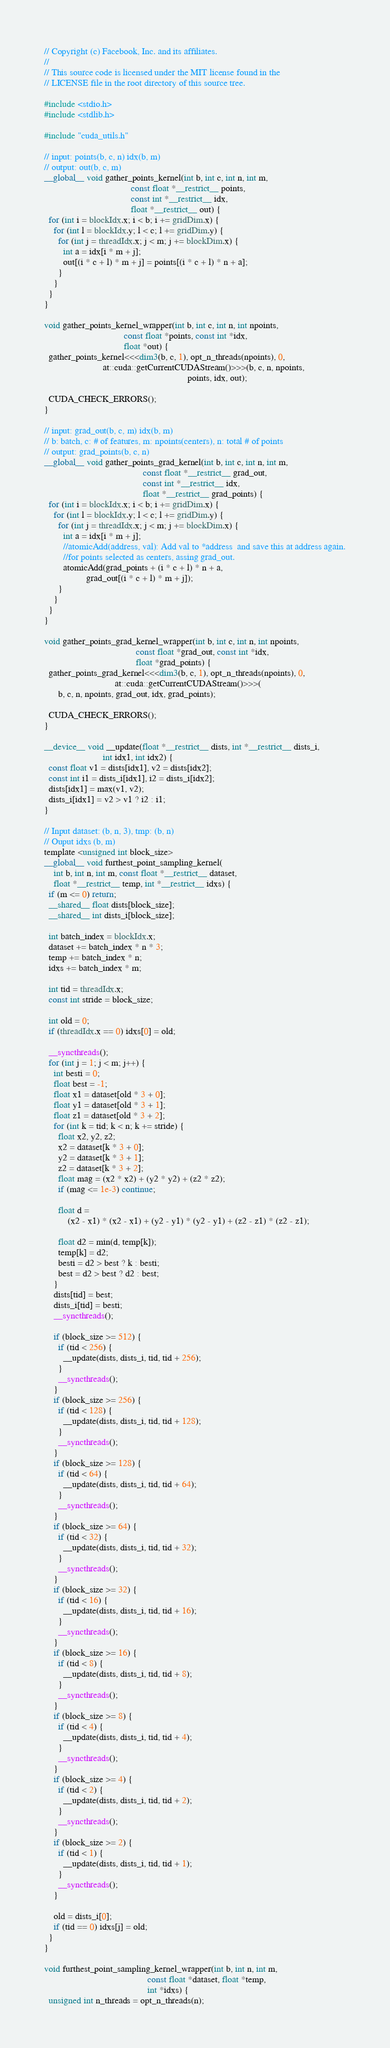Convert code to text. <code><loc_0><loc_0><loc_500><loc_500><_Cuda_>// Copyright (c) Facebook, Inc. and its affiliates.
// 
// This source code is licensed under the MIT license found in the
// LICENSE file in the root directory of this source tree.

#include <stdio.h>
#include <stdlib.h>

#include "cuda_utils.h"

// input: points(b, c, n) idx(b, m)
// output: out(b, c, m)
__global__ void gather_points_kernel(int b, int c, int n, int m,
                                     const float *__restrict__ points,
                                     const int *__restrict__ idx,
                                     float *__restrict__ out) {
  for (int i = blockIdx.x; i < b; i += gridDim.x) {
    for (int l = blockIdx.y; l < c; l += gridDim.y) {
      for (int j = threadIdx.x; j < m; j += blockDim.x) {
        int a = idx[i * m + j];
        out[(i * c + l) * m + j] = points[(i * c + l) * n + a];
      }
    }
  }
}

void gather_points_kernel_wrapper(int b, int c, int n, int npoints,
                                  const float *points, const int *idx,
                                  float *out) {
  gather_points_kernel<<<dim3(b, c, 1), opt_n_threads(npoints), 0,
                         at::cuda::getCurrentCUDAStream()>>>(b, c, n, npoints,
                                                             points, idx, out);

  CUDA_CHECK_ERRORS();
}

// input: grad_out(b, c, m) idx(b, m)
// b: batch, c: # of features, m: npoints(centers), n: total # of points
// output: grad_points(b, c, n)
__global__ void gather_points_grad_kernel(int b, int c, int n, int m,
                                          const float *__restrict__ grad_out,
                                          const int *__restrict__ idx,
                                          float *__restrict__ grad_points) {
  for (int i = blockIdx.x; i < b; i += gridDim.x) {
    for (int l = blockIdx.y; l < c; l += gridDim.y) {
      for (int j = threadIdx.x; j < m; j += blockDim.x) {
        int a = idx[i * m + j];
        //atomicAdd(address, val): Add val to *address  and save this at address again.
        //for points selected as centers, assing grad_out.
        atomicAdd(grad_points + (i * c + l) * n + a,
                  grad_out[(i * c + l) * m + j]);
      }
    }
  }
}

void gather_points_grad_kernel_wrapper(int b, int c, int n, int npoints,
                                       const float *grad_out, const int *idx,
                                       float *grad_points) {
  gather_points_grad_kernel<<<dim3(b, c, 1), opt_n_threads(npoints), 0,
                              at::cuda::getCurrentCUDAStream()>>>(
      b, c, n, npoints, grad_out, idx, grad_points);

  CUDA_CHECK_ERRORS();
}

__device__ void __update(float *__restrict__ dists, int *__restrict__ dists_i,
                         int idx1, int idx2) {
  const float v1 = dists[idx1], v2 = dists[idx2];
  const int i1 = dists_i[idx1], i2 = dists_i[idx2];
  dists[idx1] = max(v1, v2);
  dists_i[idx1] = v2 > v1 ? i2 : i1;
}

// Input dataset: (b, n, 3), tmp: (b, n)
// Ouput idxs (b, m)
template <unsigned int block_size>
__global__ void furthest_point_sampling_kernel(
    int b, int n, int m, const float *__restrict__ dataset,
    float *__restrict__ temp, int *__restrict__ idxs) {
  if (m <= 0) return;
  __shared__ float dists[block_size];
  __shared__ int dists_i[block_size];

  int batch_index = blockIdx.x;
  dataset += batch_index * n * 3;
  temp += batch_index * n;
  idxs += batch_index * m;

  int tid = threadIdx.x;
  const int stride = block_size;

  int old = 0;
  if (threadIdx.x == 0) idxs[0] = old;

  __syncthreads();
  for (int j = 1; j < m; j++) {
    int besti = 0;
    float best = -1;
    float x1 = dataset[old * 3 + 0];
    float y1 = dataset[old * 3 + 1];
    float z1 = dataset[old * 3 + 2];
    for (int k = tid; k < n; k += stride) {
      float x2, y2, z2;
      x2 = dataset[k * 3 + 0];
      y2 = dataset[k * 3 + 1];
      z2 = dataset[k * 3 + 2];
      float mag = (x2 * x2) + (y2 * y2) + (z2 * z2);
      if (mag <= 1e-3) continue;

      float d =
          (x2 - x1) * (x2 - x1) + (y2 - y1) * (y2 - y1) + (z2 - z1) * (z2 - z1);

      float d2 = min(d, temp[k]);
      temp[k] = d2;
      besti = d2 > best ? k : besti;
      best = d2 > best ? d2 : best;
    }
    dists[tid] = best;
    dists_i[tid] = besti;
    __syncthreads();

    if (block_size >= 512) {
      if (tid < 256) {
        __update(dists, dists_i, tid, tid + 256);
      }
      __syncthreads();
    }
    if (block_size >= 256) {
      if (tid < 128) {
        __update(dists, dists_i, tid, tid + 128);
      }
      __syncthreads();
    }
    if (block_size >= 128) {
      if (tid < 64) {
        __update(dists, dists_i, tid, tid + 64);
      }
      __syncthreads();
    }
    if (block_size >= 64) {
      if (tid < 32) {
        __update(dists, dists_i, tid, tid + 32);
      }
      __syncthreads();
    }
    if (block_size >= 32) {
      if (tid < 16) {
        __update(dists, dists_i, tid, tid + 16);
      }
      __syncthreads();
    }
    if (block_size >= 16) {
      if (tid < 8) {
        __update(dists, dists_i, tid, tid + 8);
      }
      __syncthreads();
    }
    if (block_size >= 8) {
      if (tid < 4) {
        __update(dists, dists_i, tid, tid + 4);
      }
      __syncthreads();
    }
    if (block_size >= 4) {
      if (tid < 2) {
        __update(dists, dists_i, tid, tid + 2);
      }
      __syncthreads();
    }
    if (block_size >= 2) {
      if (tid < 1) {
        __update(dists, dists_i, tid, tid + 1);
      }
      __syncthreads();
    }

    old = dists_i[0];
    if (tid == 0) idxs[j] = old;
  }
}

void furthest_point_sampling_kernel_wrapper(int b, int n, int m,
                                            const float *dataset, float *temp,
                                            int *idxs) {
  unsigned int n_threads = opt_n_threads(n);
</code> 